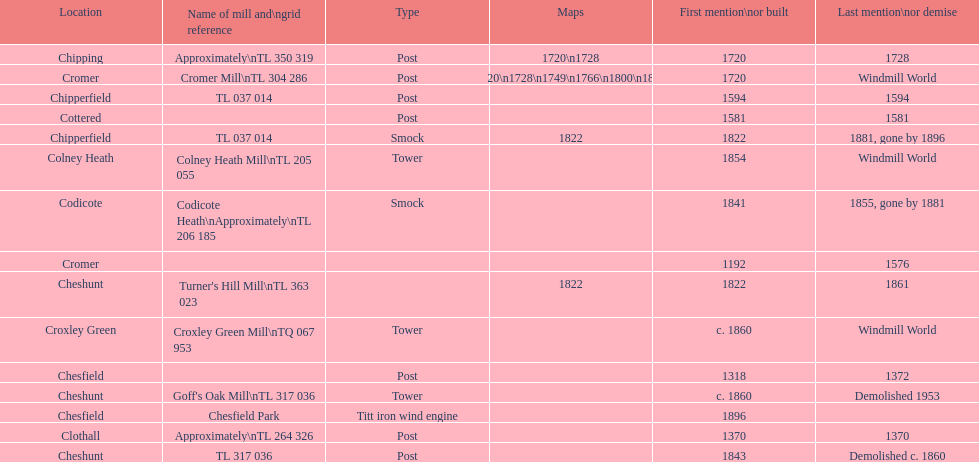What location has the most maps? Cromer. 